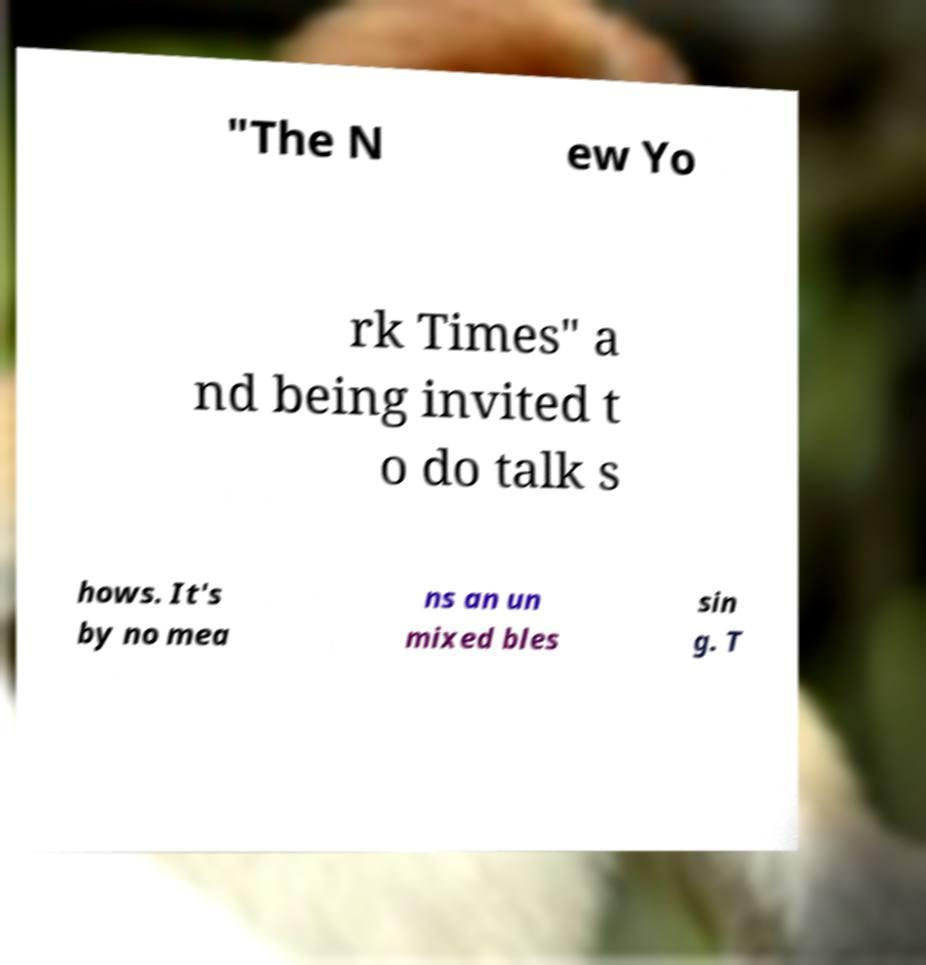Please read and relay the text visible in this image. What does it say? "The N ew Yo rk Times" a nd being invited t o do talk s hows. It's by no mea ns an un mixed bles sin g. T 